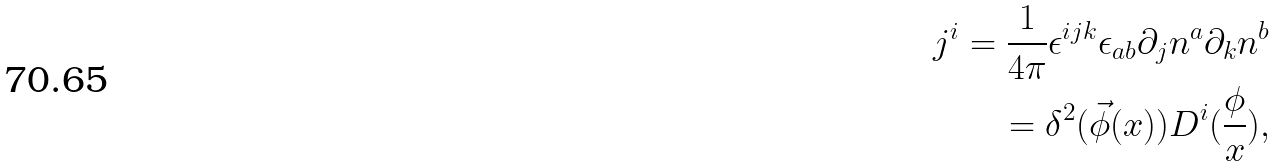Convert formula to latex. <formula><loc_0><loc_0><loc_500><loc_500>j ^ { i } = \frac { 1 } { 4 \pi } \epsilon ^ { i j k } \epsilon _ { a b } \partial _ { j } n ^ { a } \partial _ { k } n ^ { b } \\ = \delta ^ { 2 } ( \vec { \phi } ( x ) ) D ^ { i } ( \frac { \phi } { x } ) ,</formula> 